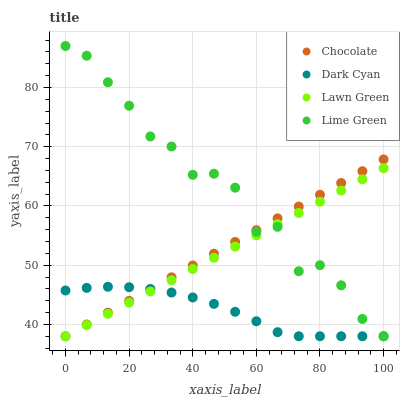Does Dark Cyan have the minimum area under the curve?
Answer yes or no. Yes. Does Lime Green have the maximum area under the curve?
Answer yes or no. Yes. Does Lawn Green have the minimum area under the curve?
Answer yes or no. No. Does Lawn Green have the maximum area under the curve?
Answer yes or no. No. Is Lawn Green the smoothest?
Answer yes or no. Yes. Is Lime Green the roughest?
Answer yes or no. Yes. Is Lime Green the smoothest?
Answer yes or no. No. Is Lawn Green the roughest?
Answer yes or no. No. Does Dark Cyan have the lowest value?
Answer yes or no. Yes. Does Lime Green have the highest value?
Answer yes or no. Yes. Does Lawn Green have the highest value?
Answer yes or no. No. Does Chocolate intersect Lime Green?
Answer yes or no. Yes. Is Chocolate less than Lime Green?
Answer yes or no. No. Is Chocolate greater than Lime Green?
Answer yes or no. No. 